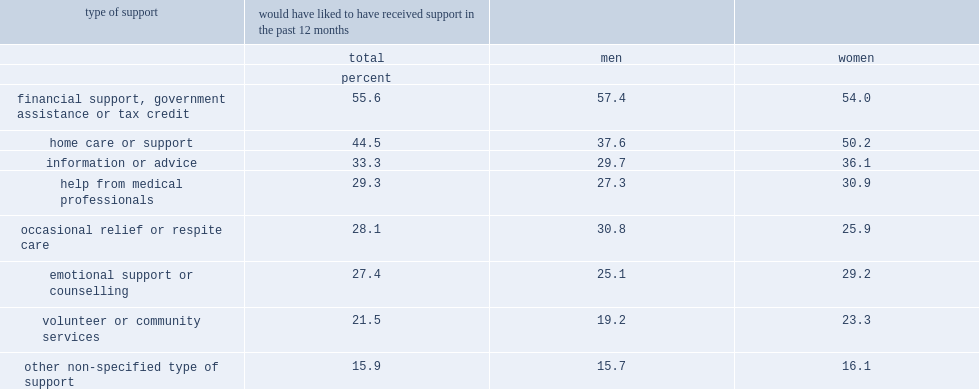What the percent of senior caregivers reported that they would have liked to have received financial support, government assistance or a tax credit? 55.6. 